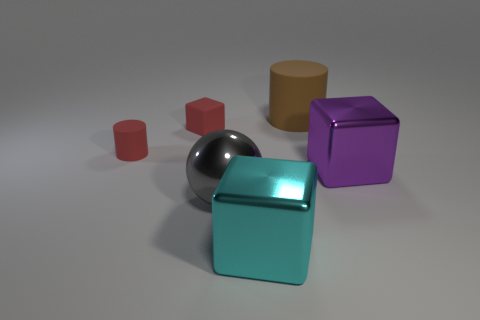Add 2 purple metal cubes. How many objects exist? 8 Subtract all large cyan shiny blocks. How many blocks are left? 2 Subtract all balls. How many objects are left? 5 Subtract all cyan blocks. How many blocks are left? 2 Add 1 tiny matte cylinders. How many tiny matte cylinders exist? 2 Subtract 1 red cubes. How many objects are left? 5 Subtract all green cubes. Subtract all cyan balls. How many cubes are left? 3 Subtract all tiny purple matte things. Subtract all small red blocks. How many objects are left? 5 Add 2 cyan metal cubes. How many cyan metal cubes are left? 3 